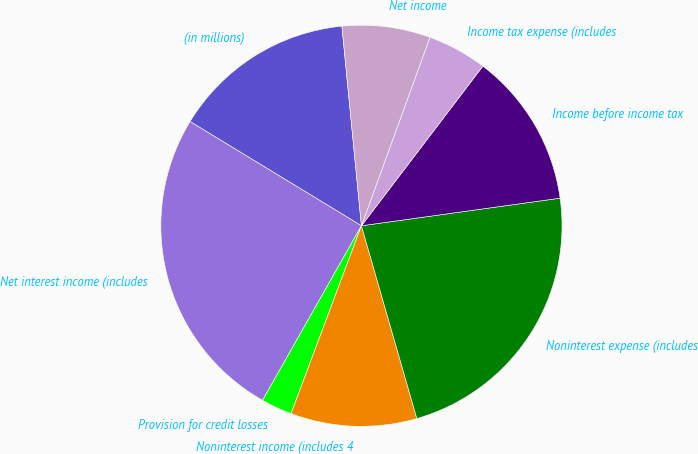Convert chart. <chart><loc_0><loc_0><loc_500><loc_500><pie_chart><fcel>(in millions)<fcel>Net interest income (includes<fcel>Provision for credit losses<fcel>Noninterest income (includes 4<fcel>Noninterest expense (includes<fcel>Income before income tax<fcel>Income tax expense (includes<fcel>Net income<nl><fcel>14.75%<fcel>25.49%<fcel>2.5%<fcel>10.16%<fcel>22.74%<fcel>12.45%<fcel>4.8%<fcel>7.1%<nl></chart> 